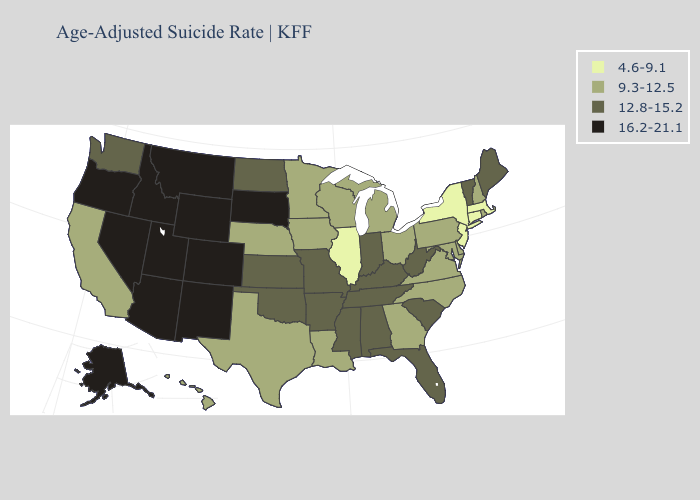Does Utah have a higher value than Illinois?
Answer briefly. Yes. Does Nevada have the lowest value in the USA?
Quick response, please. No. Among the states that border North Carolina , which have the lowest value?
Keep it brief. Georgia, Virginia. What is the highest value in the MidWest ?
Write a very short answer. 16.2-21.1. Among the states that border Louisiana , which have the highest value?
Write a very short answer. Arkansas, Mississippi. Among the states that border Iowa , does Wisconsin have the lowest value?
Write a very short answer. No. Does Louisiana have the lowest value in the South?
Give a very brief answer. Yes. Does California have the lowest value in the West?
Keep it brief. Yes. Which states have the highest value in the USA?
Quick response, please. Alaska, Arizona, Colorado, Idaho, Montana, Nevada, New Mexico, Oregon, South Dakota, Utah, Wyoming. Name the states that have a value in the range 16.2-21.1?
Give a very brief answer. Alaska, Arizona, Colorado, Idaho, Montana, Nevada, New Mexico, Oregon, South Dakota, Utah, Wyoming. What is the highest value in states that border Arizona?
Give a very brief answer. 16.2-21.1. What is the highest value in the Northeast ?
Concise answer only. 12.8-15.2. What is the value of Minnesota?
Answer briefly. 9.3-12.5. Which states hav the highest value in the MidWest?
Short answer required. South Dakota. 